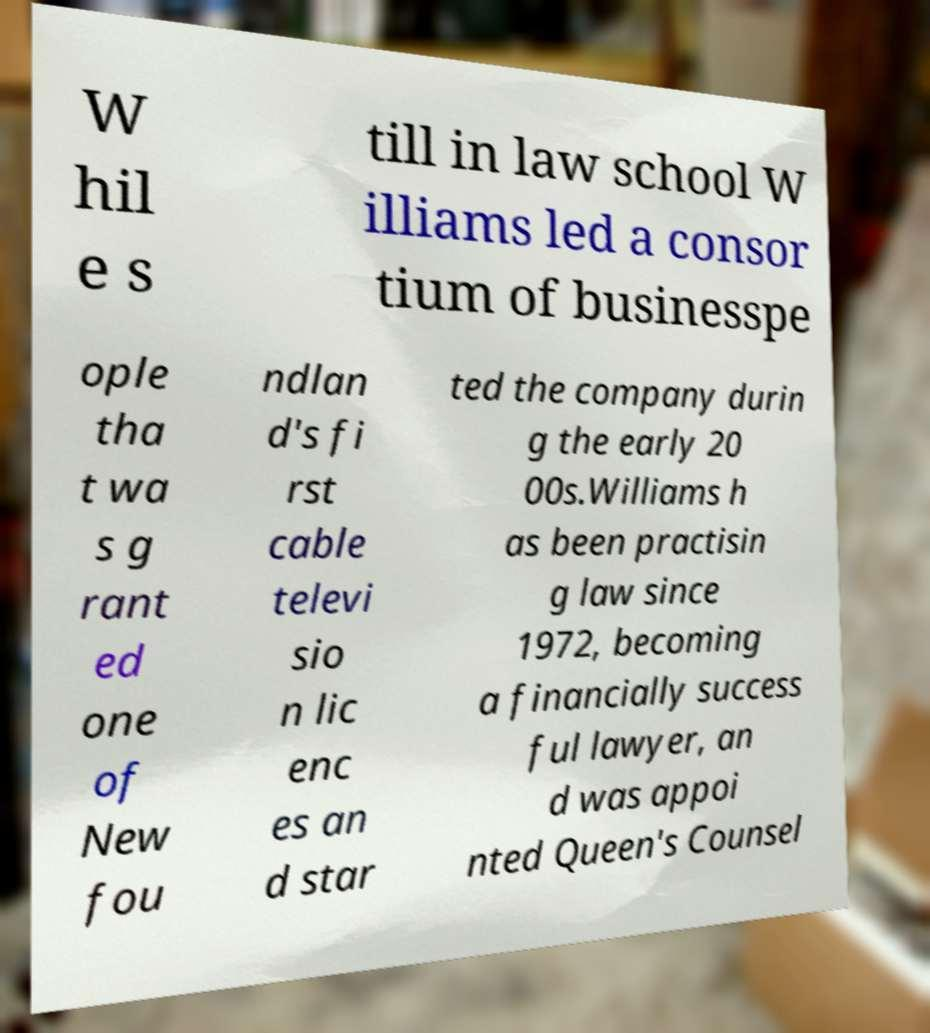For documentation purposes, I need the text within this image transcribed. Could you provide that? W hil e s till in law school W illiams led a consor tium of businesspe ople tha t wa s g rant ed one of New fou ndlan d's fi rst cable televi sio n lic enc es an d star ted the company durin g the early 20 00s.Williams h as been practisin g law since 1972, becoming a financially success ful lawyer, an d was appoi nted Queen's Counsel 